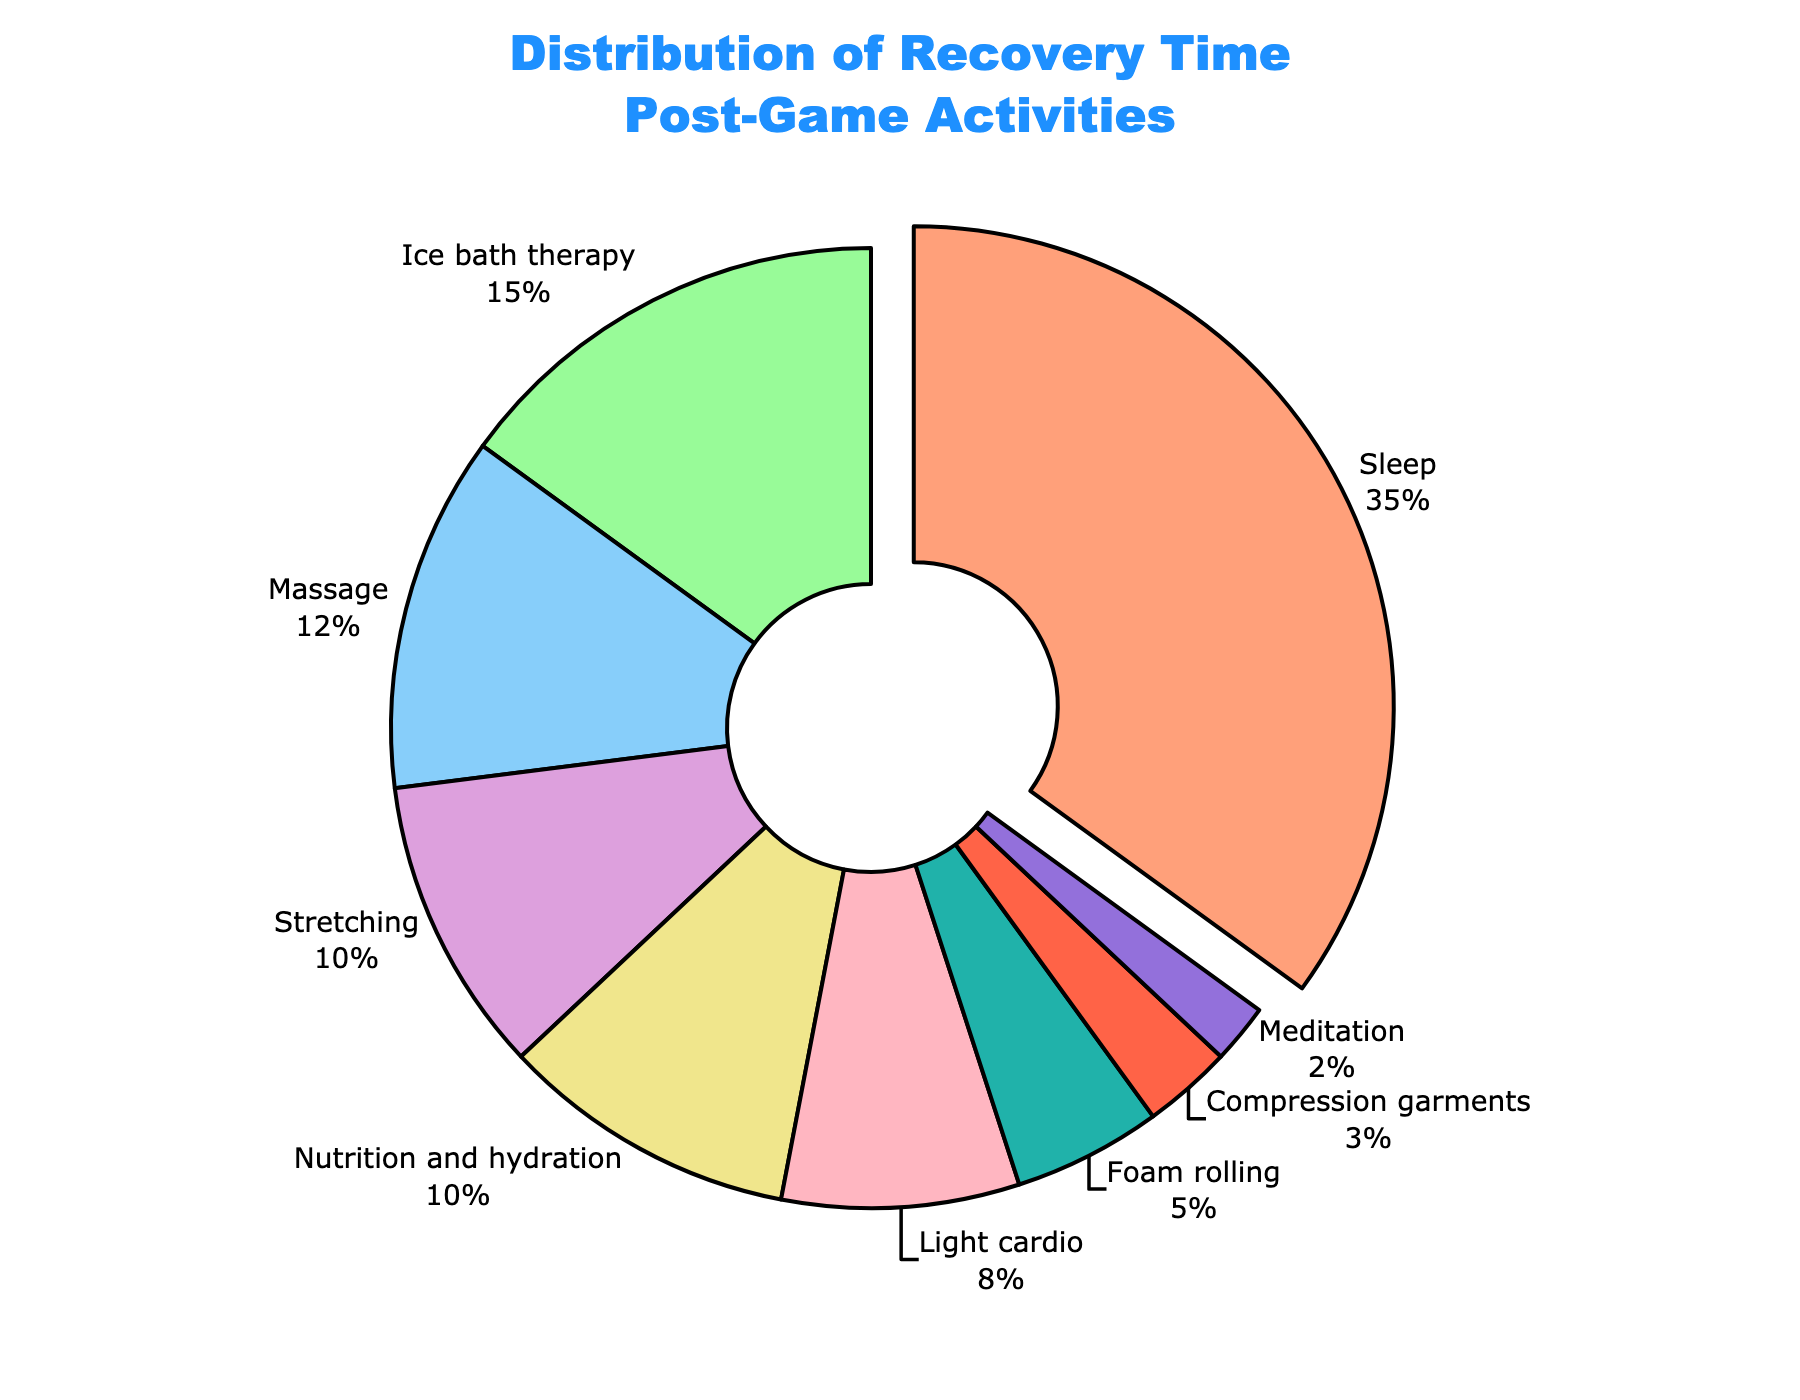Which activity has the highest percentage of recovery time spent? The pie chart shows different activities with their respective percentages. The slice that has a portion pulled out and the highest percentage number displayed is the activity with the highest percentage of recovery time spent. This is "Sleep" with 35%.
Answer: Sleep What is the combined percentage of time spent on "Ice bath therapy" and "Massage"? To find the combined percentage, add the percentages for "Ice bath therapy" (15%) and "Massage" (12%) from the pie chart, resulting in 15% + 12% = 27%.
Answer: 27% Is more time spent on "Stretching" or "Light cardio"? Compare the percentages from the pie chart: "Stretching" has 10% and "Light cardio" has 8%. Since 10% > 8%, more time is spent on "Stretching".
Answer: Stretching What activities together make up exactly half of the recovery time? To determine which activities sum to 50%, start by adding the highest percentages until the sum equals 50%. The first three activities: "Sleep" (35%), "Ice bath therapy" (15%), together sum to 50%.
Answer: Sleep and Ice bath therapy Which activity occupies the smallest portion of the recovery time? The pie chart shows the percentages for each activity. The smallest percentage is "Meditation" with 2%, indicated by the smallest slice in the chart.
Answer: Meditation How does the percentage of time spent on "Nutrition and hydration" compare to the time spent on "Foam rolling"? Compare the percentages of both activities from the pie chart: "Nutrition and hydration" has 10%, while "Foam rolling" has 5%. Since 10% > 5%, more time is spent on "Nutrition and hydration" than "Foam rolling".
Answer: Nutrition and hydration What percentage of recovery time is spent on activities other than "Sleep"? Subtract the percentage for "Sleep" (35%) from 100%. So, 100% - 35% = 65%.
Answer: 65% Calculate the difference in recovery time between "Massage" and "Compression garments". Subtract the percentage for "Compression garments" (3%) from "Massage" (12%). So, 12% - 3% = 9%.
Answer: 9% If you sum up the percentages of "Stretching", "Light cardio", and "Foam rolling", what do you get? Add the percentages from the pie chart for "Stretching" (10%), "Light cardio" (8%), and "Foam rolling" (5%). So, 10% + 8% + 5% = 23%.
Answer: 23% What is the average percentage of time spent on "Compression garments" and "Meditation"? To find the average, add the percentages for "Compression garments" (3%) and "Meditation" (2%) and then divide by 2. (3% + 2%) / 2 = 2.5%.
Answer: 2.5% 